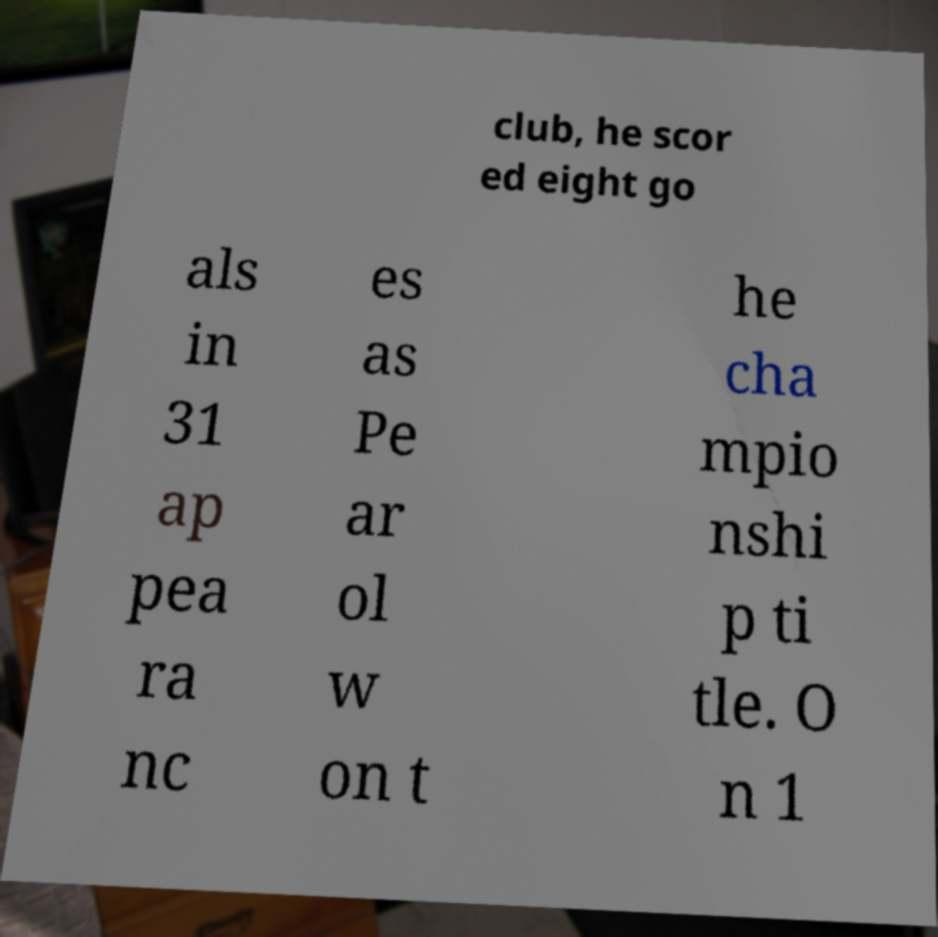Could you extract and type out the text from this image? club, he scor ed eight go als in 31 ap pea ra nc es as Pe ar ol w on t he cha mpio nshi p ti tle. O n 1 